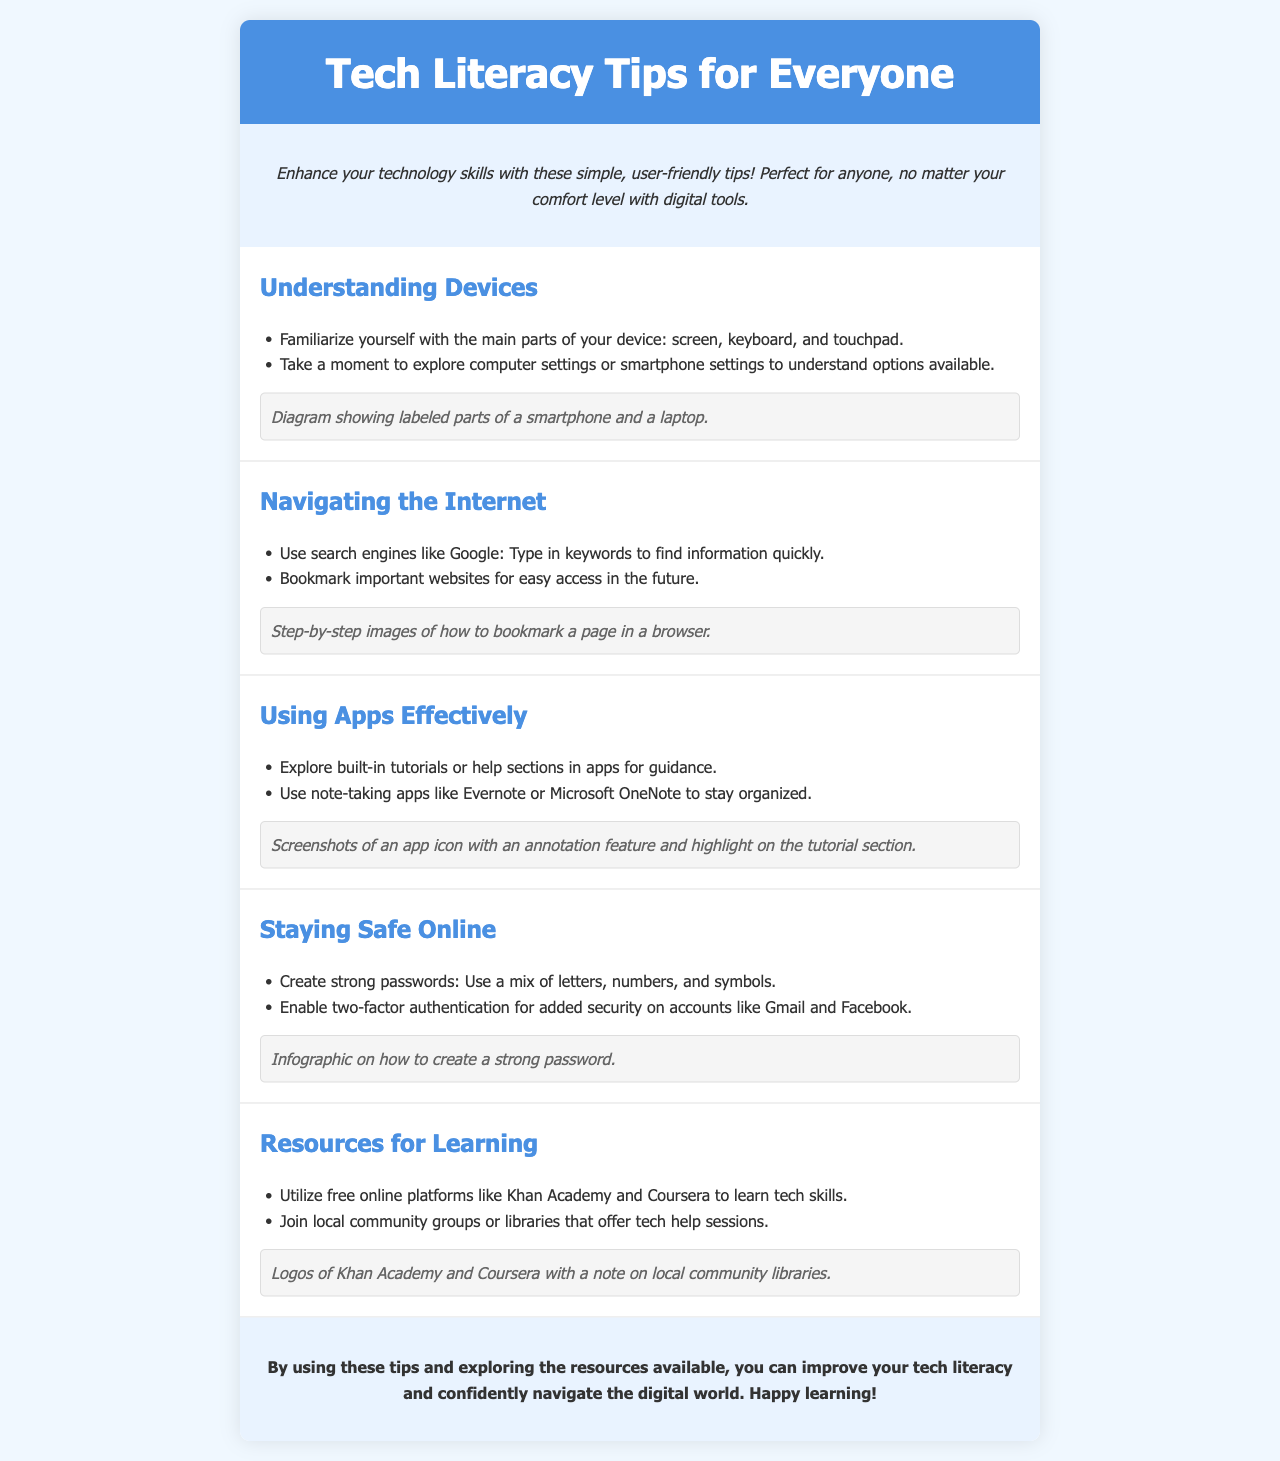What is the title of the brochure? The title of the brochure is indicated at the top of the document.
Answer: Tech Literacy Tips for Everyone How many sections are there in the brochure? The brochure has multiple distinct sections that each provide a different topic or tip.
Answer: Five What is one example of a resource for learning mentioned? The document lists specific online platforms and local resources as places to gain skills.
Answer: Khan Academy What is one tip for staying safe online? The brochure provides practical advice on online security measures that can be easily retrieved from the content.
Answer: Enable two-factor authentication What visual is included in the 'Using Apps Effectively' section? Each section of the brochure has a visual that illustrates the content being discussed.
Answer: Screenshots of an app icon with an annotation feature Why is it suggested to use bookmark features in browsers? The document describes practices for easy navigation and access to important information.
Answer: For easy access in the future What type of language is used in the brochure? The brochure aims to cater to a wide audience by using language that is accessible and easy to understand.
Answer: Easy language What visual aids are used to support tips in the document? Visual aids are included to help convey the information in a clear and engaging manner throughout the brochure.
Answer: Step-by-step images 